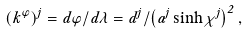<formula> <loc_0><loc_0><loc_500><loc_500>( k ^ { \varphi } ) ^ { j } = d \varphi / d \lambda = d ^ { j } / \left ( a ^ { j } \sinh \chi ^ { j } \right ) ^ { 2 } ,</formula> 